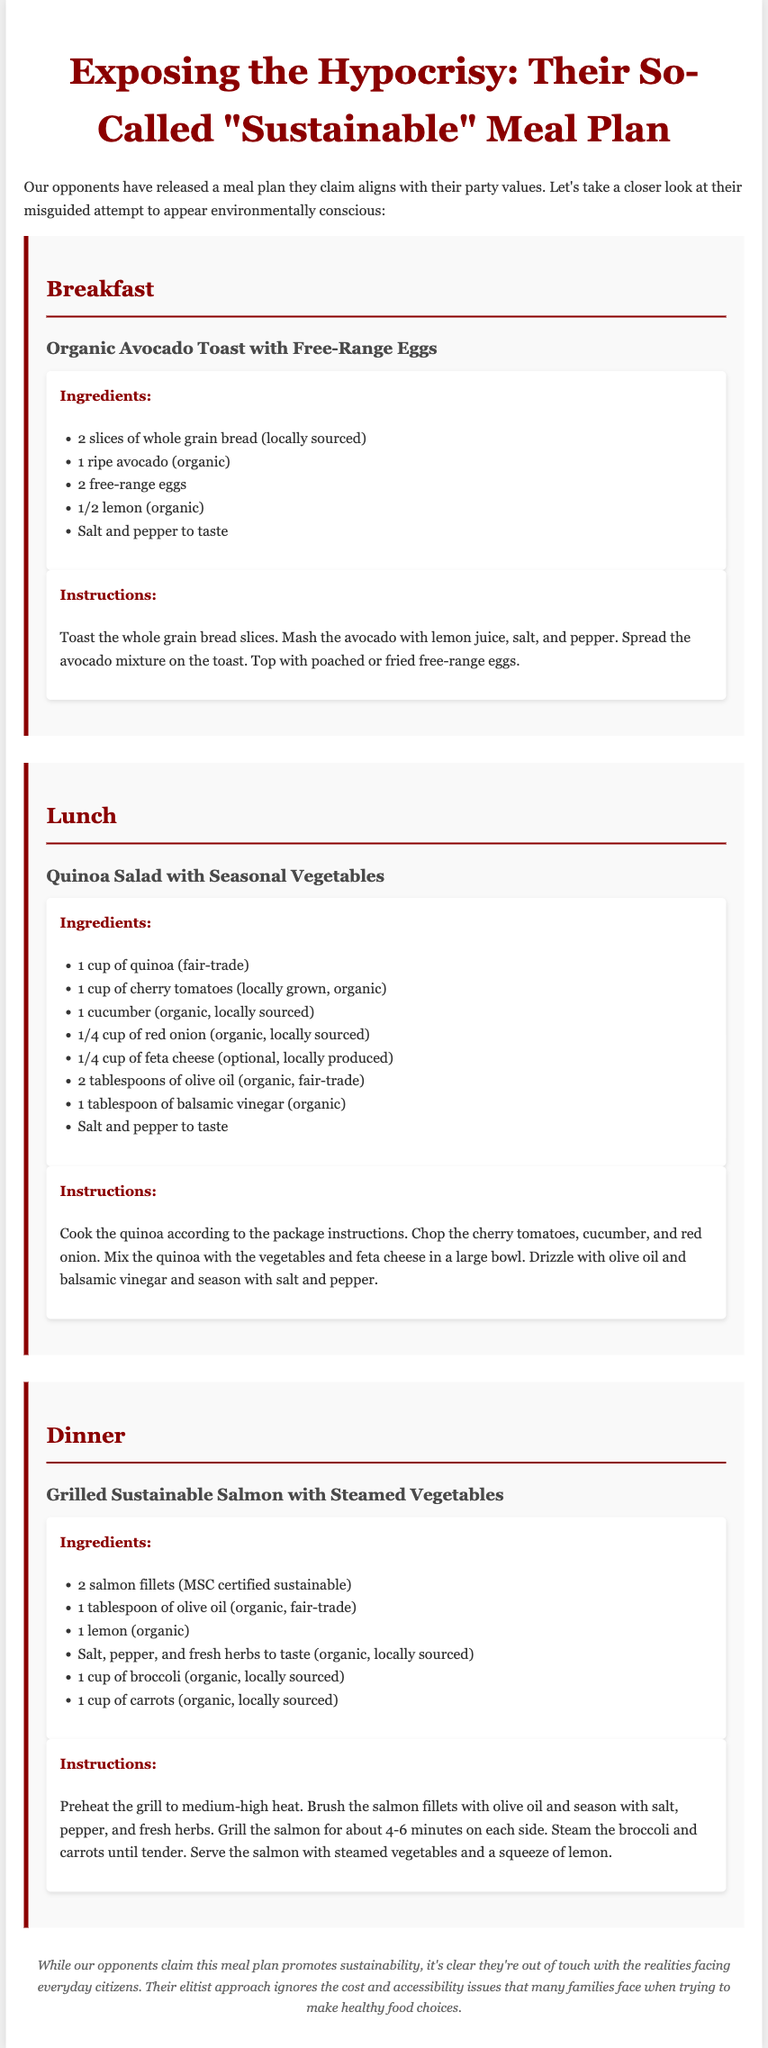What is the title of the document? The title of the document is stated in the <title> tag in the HTML code.
Answer: Exposing the Hypocrisy: Their So-Called "Sustainable" Meal Plan How many meals are included in the plan? The document outlines three main meals, which can be counted in the meal section.
Answer: Three What is one ingredient used in the breakfast recipe? The breakfast recipe lists several ingredients, and one can be chosen from the provided list.
Answer: Avocado What is the source of the quinoa in the lunch recipe? The lunch recipe specifies that the quinoa is a specific type, providing its origin attributing to ethical shopping.
Answer: Fair-trade What type of salmon is used for dinner? The dinner recipe mentions a certification that indicates the sustainability of the salmon.
Answer: MSC certified sustainable What is the main vegetable served with dinner? The dinner recipe includes specific vegetables, one of which can be identified as the main one served.
Answer: Broccoli How many tablespoons of olive oil are used in the quinoa salad? The lunch recipe provides a precise measurement for olive oil in the ingredients list.
Answer: Two tablespoons What does the document imply about the opponents' meal plan? The footnote offers insights and opinions about the efficacy of their meal choices based on various factors.
Answer: Elitist approach What is the main focus of the document? The overall summary presented at the beginning highlights the core intent of the writing, which is to question the authenticity of another's claim.
Answer: Sustainability 